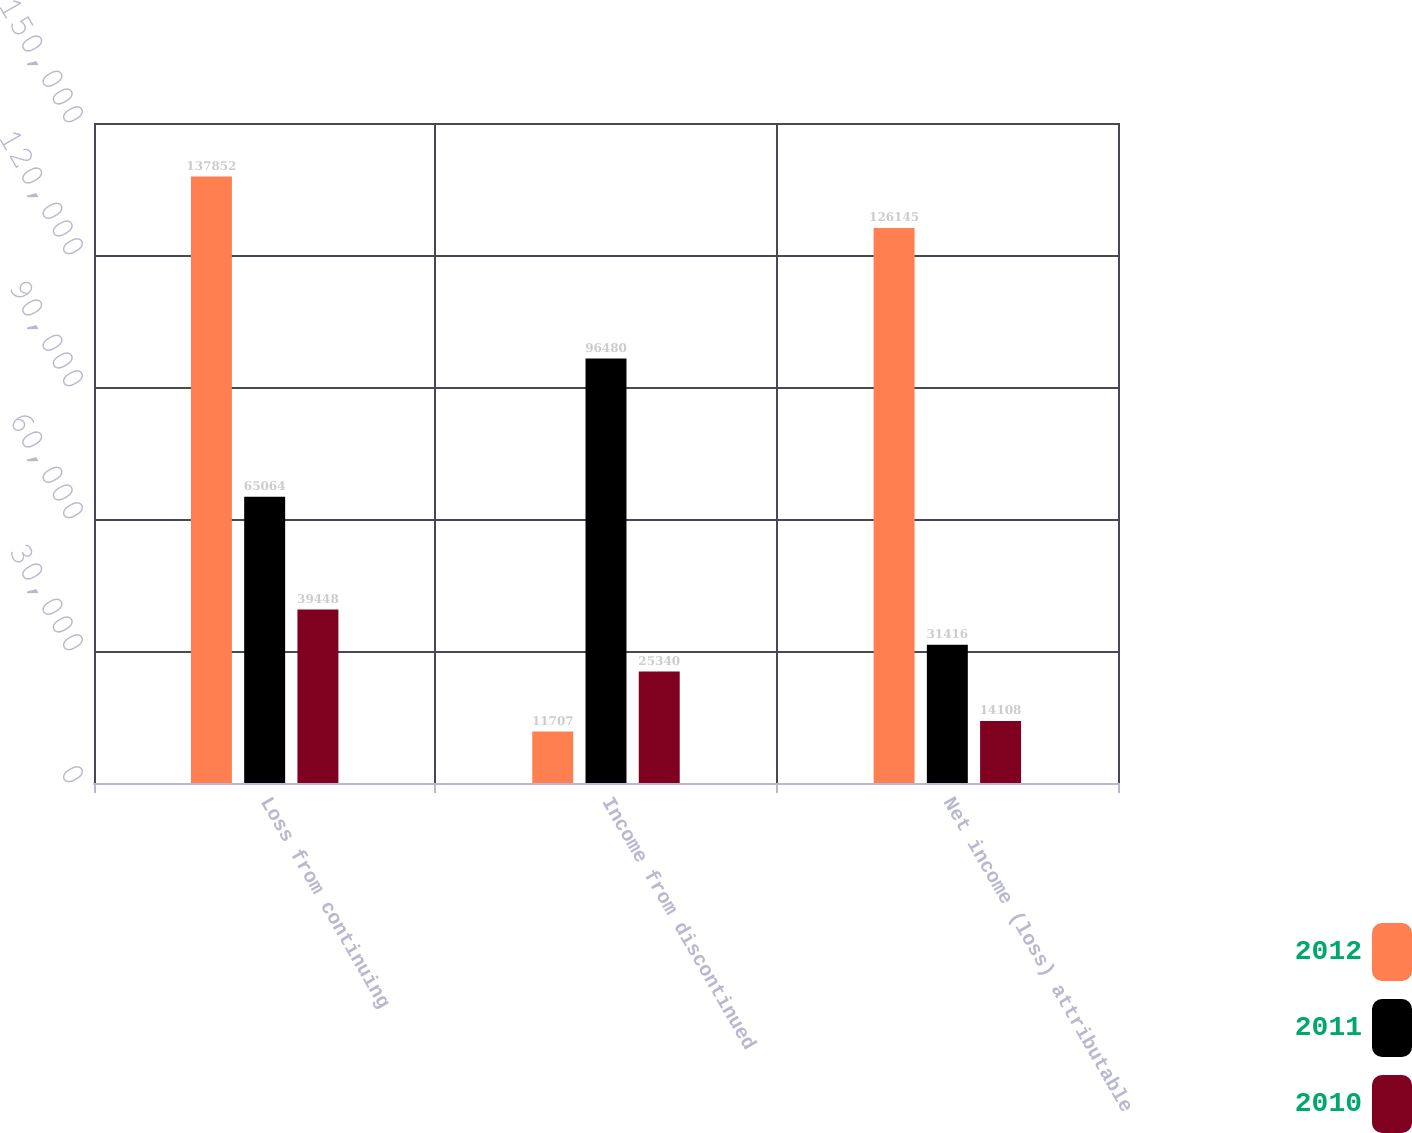Convert chart. <chart><loc_0><loc_0><loc_500><loc_500><stacked_bar_chart><ecel><fcel>Loss from continuing<fcel>Income from discontinued<fcel>Net income (loss) attributable<nl><fcel>2012<fcel>137852<fcel>11707<fcel>126145<nl><fcel>2011<fcel>65064<fcel>96480<fcel>31416<nl><fcel>2010<fcel>39448<fcel>25340<fcel>14108<nl></chart> 